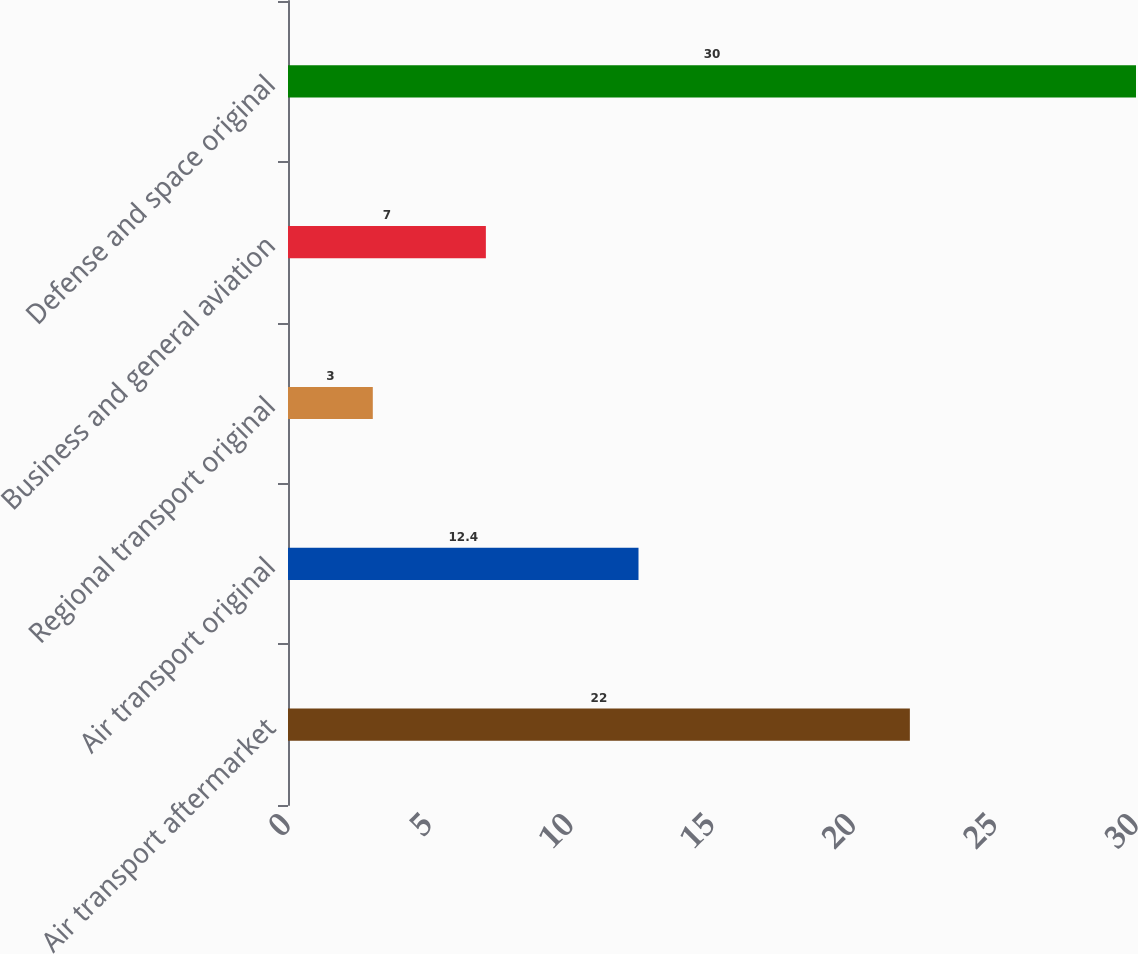<chart> <loc_0><loc_0><loc_500><loc_500><bar_chart><fcel>Air transport aftermarket<fcel>Air transport original<fcel>Regional transport original<fcel>Business and general aviation<fcel>Defense and space original<nl><fcel>22<fcel>12.4<fcel>3<fcel>7<fcel>30<nl></chart> 